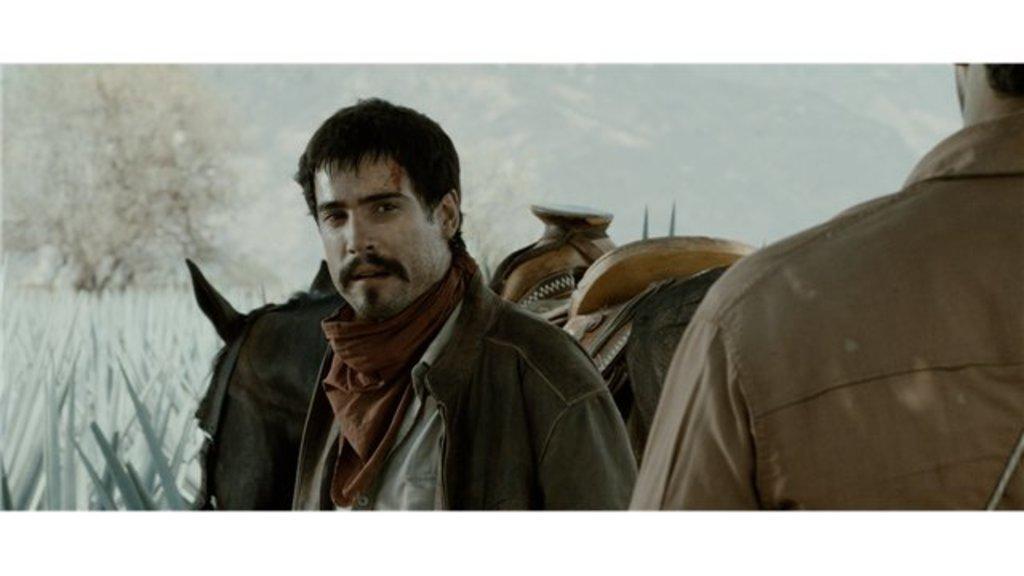Please provide a concise description of this image. In the foreground of the image there is a person wearing a jacket. To the right side of the image there is another person. In the background of the image there are trees. There is a horse. To the left side of the image there are plants. 